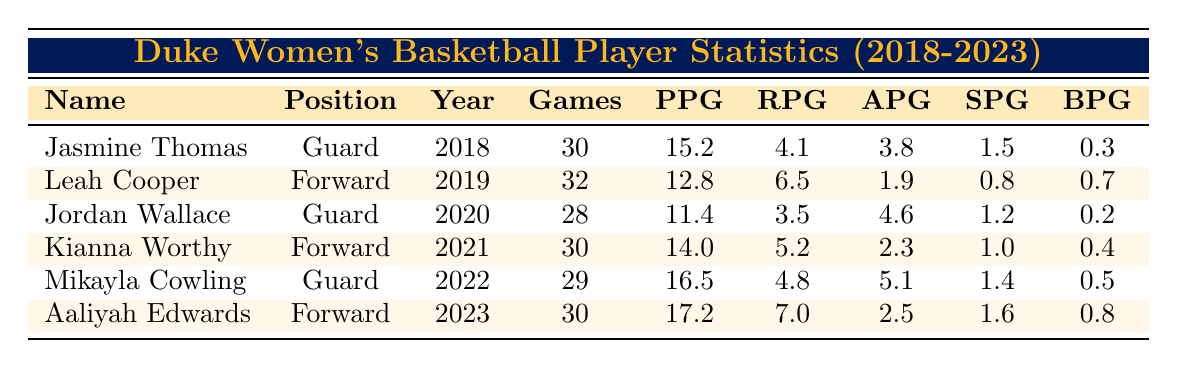What is the highest points per game (PPG) among the players listed? The highest PPG can be found by comparing the values in the "PPG" column. The highest value is 17.2 from Aaliyah Edwards.
Answer: 17.2 Which player had the most games played? By examining the "Games" column, Leah Cooper played the most games at 32.
Answer: Leah Cooper How many rebounds per game (RPG) did Mikayla Cowling average? Referring to the "RPG" column, Mikayla Cowling averaged 4.8 rebounds per game.
Answer: 4.8 What is the average PPG of the players from 2018 to 2022? First, sum the PPG: 15.2 + 12.8 + 11.4 + 14.0 + 16.5 = 70.9. Then divide by 5 players, which results in 70.9 / 5 = 14.18.
Answer: 14.18 Did any player record more than 6 rebounds per game? Check the "RPG" values: Aaliyah Edwards had 7.0 RPG, which is more than 6, so the answer is yes.
Answer: Yes Which player improved their PPG from the previous year? Comparing PPG of each year: Aaliyah Edwards (17.2) compared to Mikayla Cowling (16.5) shows an increase, and similarly for Kianna Worthy (14.0) from Jordan Wallace (11.4).
Answer: Aaliyah Edwards and Kianna Worthy What is the total number of assists per game (APG) for all players? Add all APG values: 3.8 + 1.9 + 4.6 + 2.3 + 5.1 + 2.5 = 20.2
Answer: 20.2 Who had the lowest number of steals per game (SPG) and what was the value? The "SPG" column shows Jordan Wallace had the lowest SPG of 1.2.
Answer: Jordan Wallace, 1.2 If you compare the blocks per game (BPG) of forwards only, who has the highest? Aaliyah Edwards (0.8) and Kianna Worthy (0.4) are the forwards; thus, Aaliyah Edwards has the highest BPG among them.
Answer: Aaliyah Edwards How does the total games played by Duke women's basketball players in 2020 compare to 2021? In 2020, Games played were 28 (Jordan Wallace), and in 2021 it was 30 (Kianna Worthy). Thus, 2021 had more games played by 2.
Answer: 2021 had 2 more games What is the trend in points per game (PPG) from 2018 to 2023? By reviewing PPG: 15.2, 12.8, 11.4, 14.0, 16.5, 17.2 shows an overall increasing trend from 2018 to 2023.
Answer: Increasing trend 